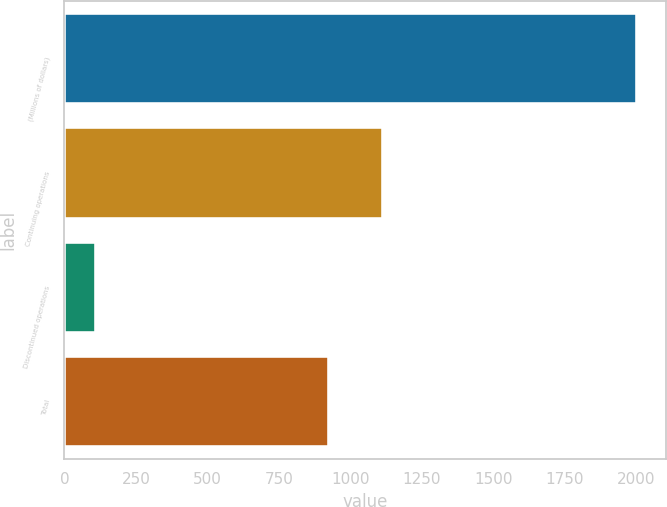<chart> <loc_0><loc_0><loc_500><loc_500><bar_chart><fcel>(Millions of dollars)<fcel>Continuing operations<fcel>Discontinued operations<fcel>Total<nl><fcel>2003<fcel>1115.3<fcel>110<fcel>926<nl></chart> 